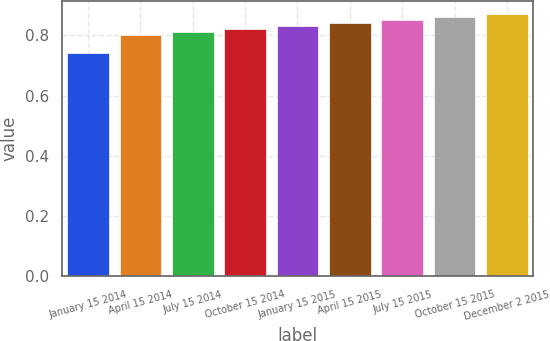Convert chart to OTSL. <chart><loc_0><loc_0><loc_500><loc_500><bar_chart><fcel>January 15 2014<fcel>April 15 2014<fcel>July 15 2014<fcel>October 15 2014<fcel>January 15 2015<fcel>April 15 2015<fcel>July 15 2015<fcel>October 15 2015<fcel>December 2 2015<nl><fcel>0.74<fcel>0.8<fcel>0.81<fcel>0.82<fcel>0.83<fcel>0.84<fcel>0.85<fcel>0.86<fcel>0.87<nl></chart> 